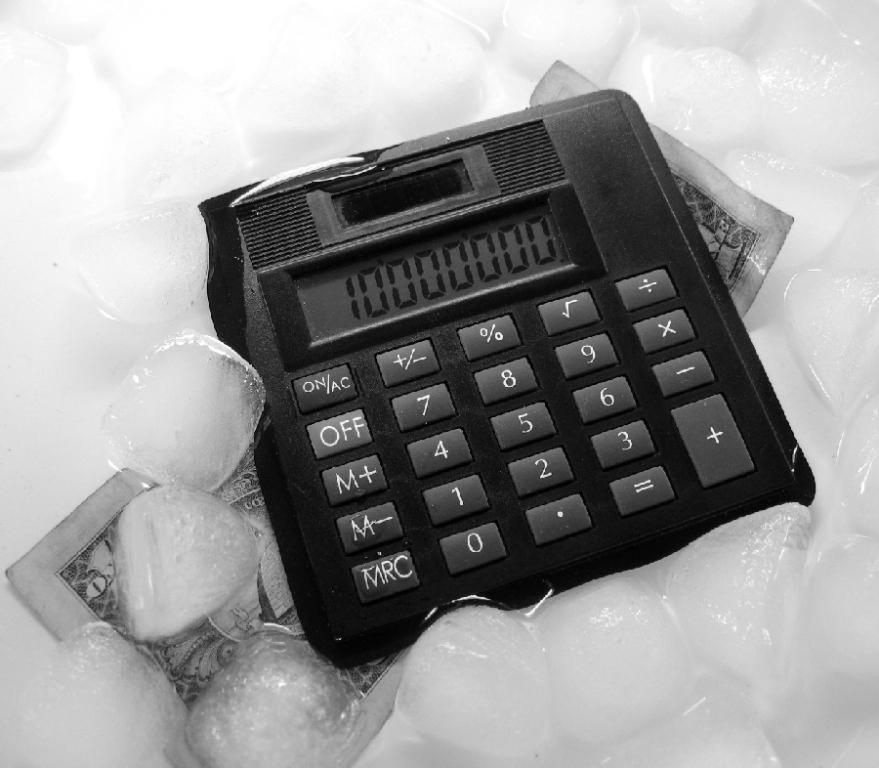<image>
Summarize the visual content of the image. A black calculator has the numbers of 10000000 displayed. 